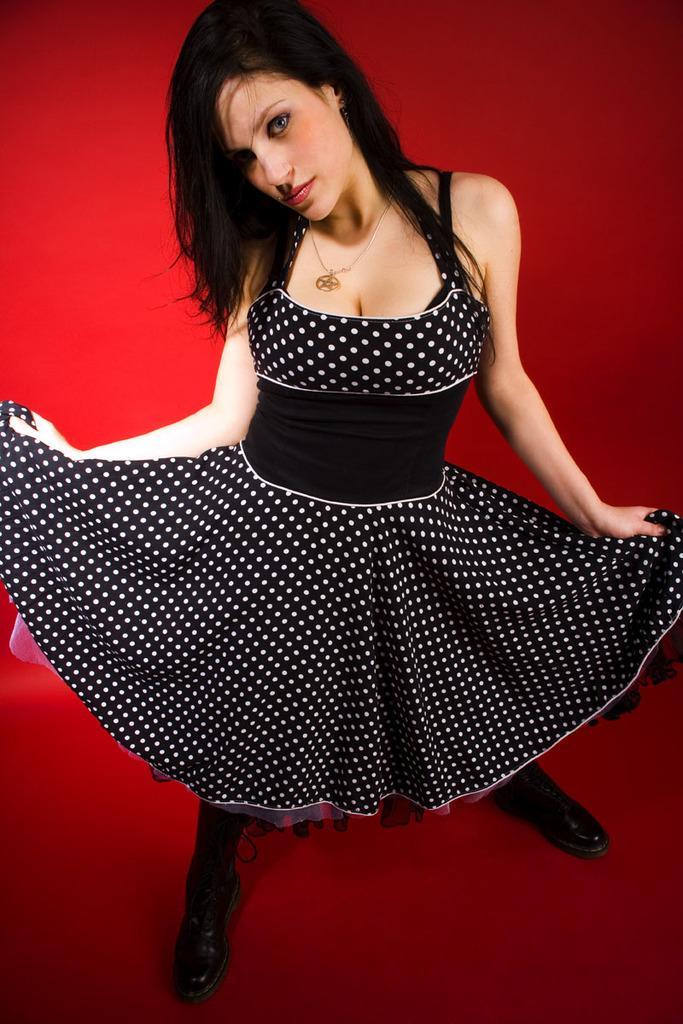Can you describe this image briefly? In the image there is a woman she is wearing black dress and black shoes and posing for the photo the background of the woman is red in color. 